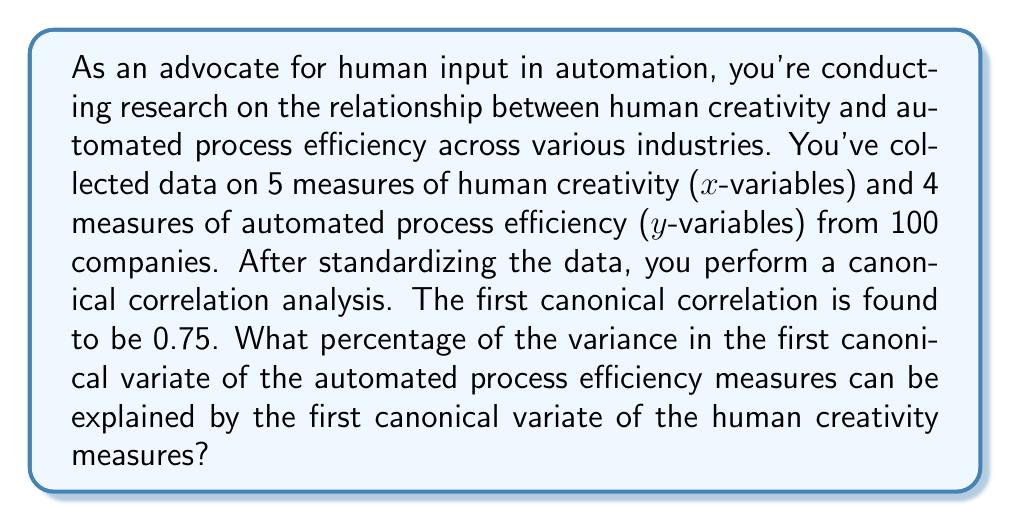Can you solve this math problem? To solve this problem, we need to understand the concept of canonical correlation analysis and how to interpret its results. Let's break it down step-by-step:

1) Canonical correlation analysis (CCA) is a method used to identify and measure the associations between two sets of variables. In this case, we have:
   - Set X: 5 measures of human creativity
   - Set Y: 4 measures of automated process efficiency

2) The canonical correlation ($r_c$) represents the maximum correlation between linear combinations of the variables in Set X and Set Y. We're given that the first canonical correlation is 0.75.

3) To determine the percentage of variance explained, we need to square the canonical correlation. This gives us the canonical R-squared ($R_c^2$).

4) The formula for this calculation is:

   $$R_c^2 = r_c^2 \times 100\%$$

5) Plugging in our value:

   $$R_c^2 = (0.75)^2 \times 100\% = 0.5625 \times 100\% = 56.25\%$$

6) This means that 56.25% of the variance in the first canonical variate of the automated process efficiency measures (Y) can be explained by the first canonical variate of the human creativity measures (X).

This result suggests a moderate to strong relationship between human creativity and automated process efficiency, supporting the importance of human input in automation processes.
Answer: 56.25% 